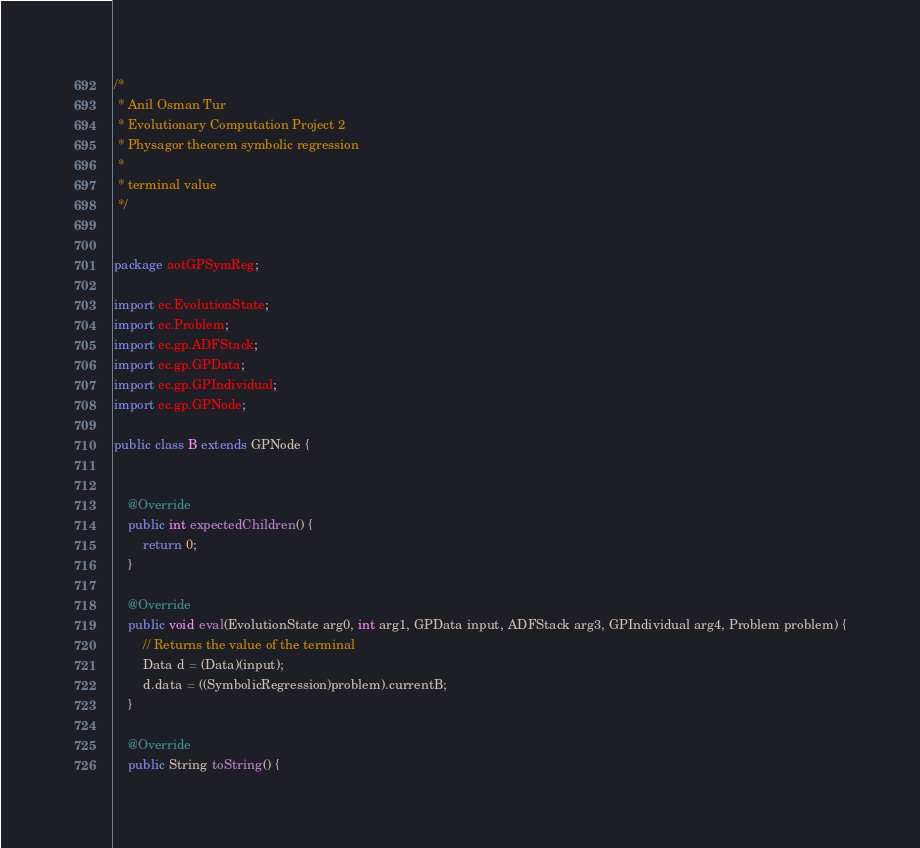Convert code to text. <code><loc_0><loc_0><loc_500><loc_500><_Java_>/*
 * Anil Osman Tur
 * Evolutionary Computation Project 2
 * Physagor theorem symbolic regression
 * 
 * terminal value 
 */


package aotGPSymReg;

import ec.EvolutionState;
import ec.Problem;
import ec.gp.ADFStack;
import ec.gp.GPData;
import ec.gp.GPIndividual;
import ec.gp.GPNode;

public class B extends GPNode {

	
	@Override
	public int expectedChildren() {
		return 0;
	}

	@Override
	public void eval(EvolutionState arg0, int arg1, GPData input, ADFStack arg3, GPIndividual arg4, Problem problem) {
		// Returns the value of the terminal
		Data d = (Data)(input);
		d.data = ((SymbolicRegression)problem).currentB;
	}

	@Override
	public String toString() {</code> 